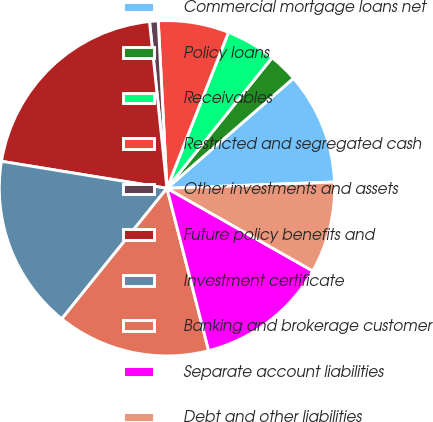Convert chart to OTSL. <chart><loc_0><loc_0><loc_500><loc_500><pie_chart><fcel>Commercial mortgage loans net<fcel>Policy loans<fcel>Receivables<fcel>Restricted and segregated cash<fcel>Other investments and assets<fcel>Future policy benefits and<fcel>Investment certificate<fcel>Banking and brokerage customer<fcel>Separate account liabilities<fcel>Debt and other liabilities<nl><fcel>10.8%<fcel>2.82%<fcel>4.81%<fcel>6.81%<fcel>0.83%<fcel>20.77%<fcel>16.78%<fcel>14.79%<fcel>12.79%<fcel>8.8%<nl></chart> 